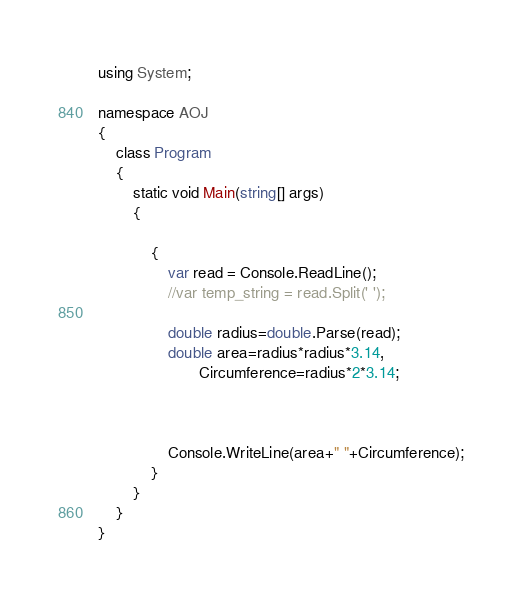<code> <loc_0><loc_0><loc_500><loc_500><_C#_>using System;

namespace AOJ
{
    class Program
    {
        static void Main(string[] args)
        {

            {
                var read = Console.ReadLine();
                //var temp_string = read.Split(' ');

                double radius=double.Parse(read);
                double area=radius*radius*3.14,
                       Circumference=radius*2*3.14;



                Console.WriteLine(area+" "+Circumference);
            }
        }
    }
}</code> 